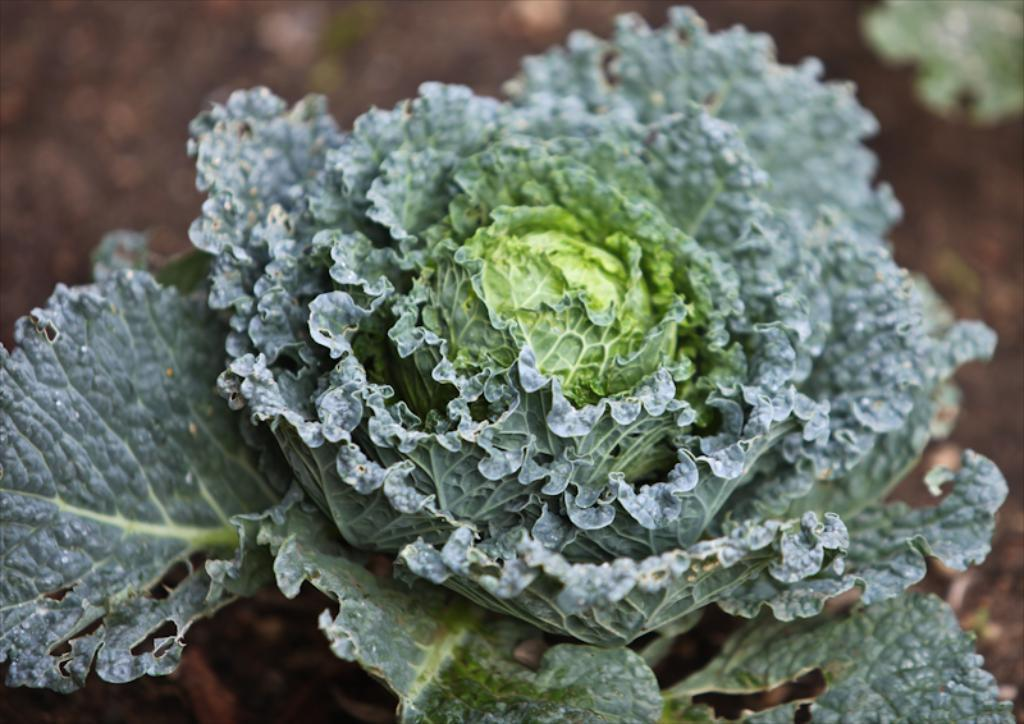What type of food is present in the image? There is a vegetable in the image. What type of flower can be seen blooming in the image? There is no flower present in the image; it features a vegetable. What season is depicted in the image? The image does not depict a specific season, as it only shows a vegetable. 